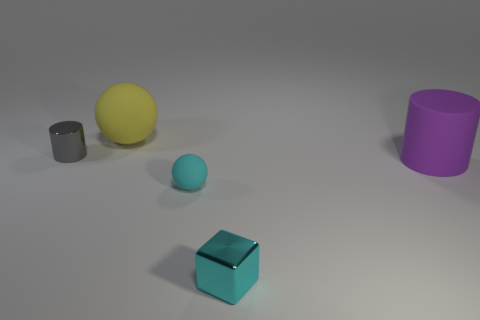Is the purple object the same shape as the yellow thing?
Your response must be concise. No. What is the size of the purple object that is the same shape as the small gray metallic object?
Your answer should be very brief. Large. There is a object that is the same color as the tiny shiny block; what is its material?
Provide a short and direct response. Rubber. What number of small objects are the same color as the tiny cylinder?
Provide a short and direct response. 0. Are there the same number of cyan spheres to the left of the tiny matte thing and yellow rubber objects?
Provide a succinct answer. No. The small rubber object has what color?
Your answer should be very brief. Cyan. What is the size of the cyan thing that is the same material as the big purple cylinder?
Your response must be concise. Small. What color is the block that is the same material as the gray thing?
Your response must be concise. Cyan. Is there another green rubber cylinder of the same size as the matte cylinder?
Offer a very short reply. No. What is the material of the small cyan thing that is the same shape as the big yellow thing?
Provide a succinct answer. Rubber. 